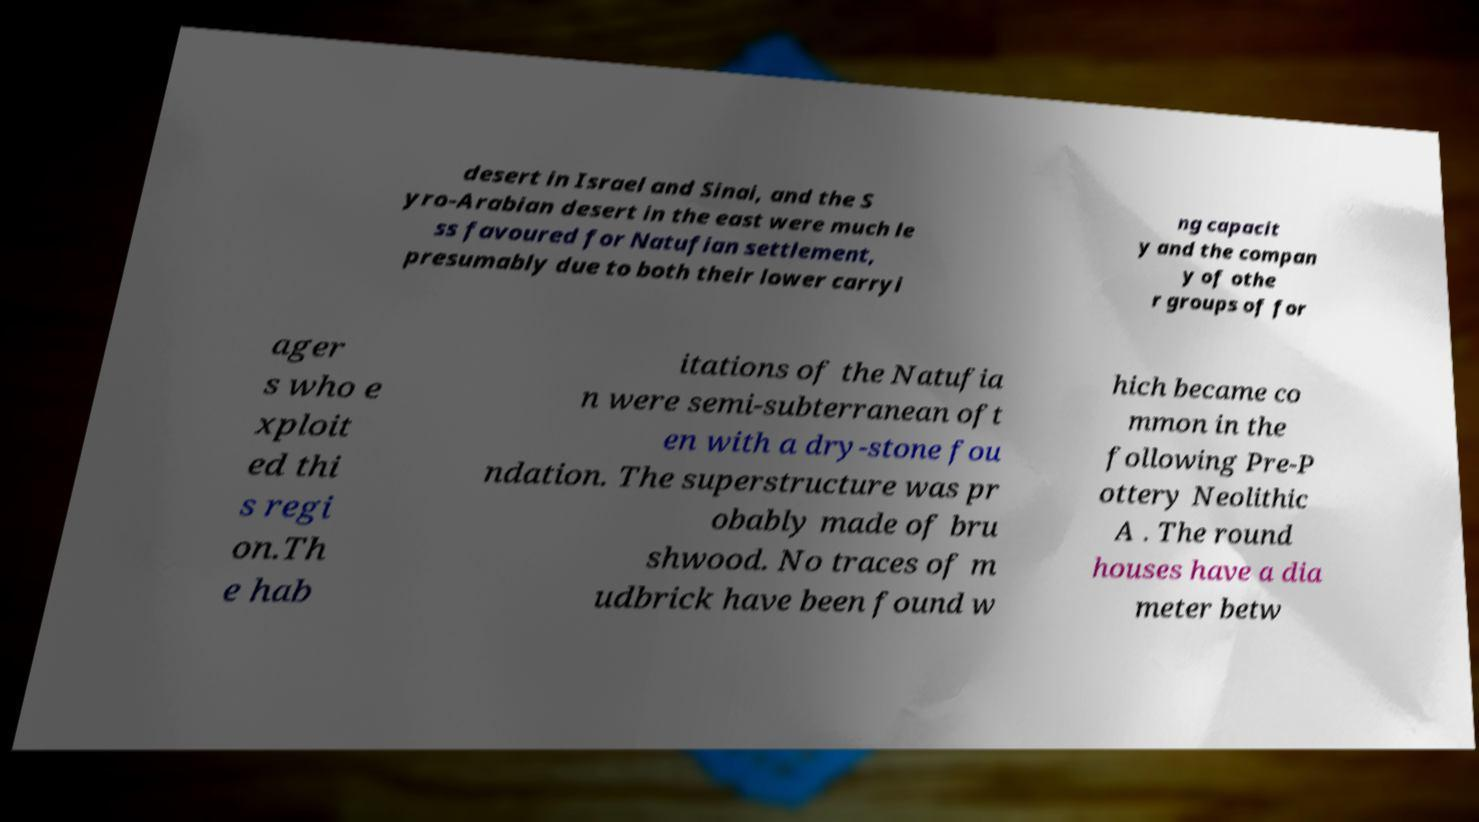There's text embedded in this image that I need extracted. Can you transcribe it verbatim? desert in Israel and Sinai, and the S yro-Arabian desert in the east were much le ss favoured for Natufian settlement, presumably due to both their lower carryi ng capacit y and the compan y of othe r groups of for ager s who e xploit ed thi s regi on.Th e hab itations of the Natufia n were semi-subterranean oft en with a dry-stone fou ndation. The superstructure was pr obably made of bru shwood. No traces of m udbrick have been found w hich became co mmon in the following Pre-P ottery Neolithic A . The round houses have a dia meter betw 